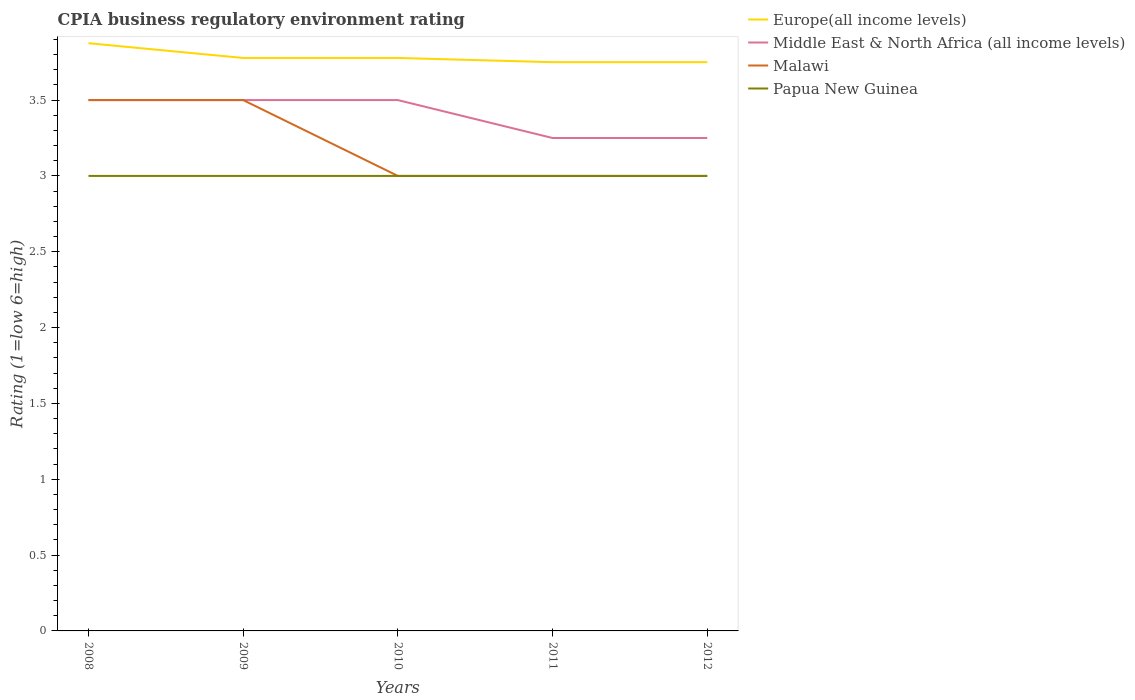Is the number of lines equal to the number of legend labels?
Offer a terse response. Yes. What is the total CPIA rating in Europe(all income levels) in the graph?
Provide a short and direct response. 0.12. What is the difference between the highest and the second highest CPIA rating in Middle East & North Africa (all income levels)?
Provide a short and direct response. 0.25. What is the difference between two consecutive major ticks on the Y-axis?
Provide a succinct answer. 0.5. How are the legend labels stacked?
Your answer should be very brief. Vertical. What is the title of the graph?
Provide a succinct answer. CPIA business regulatory environment rating. What is the label or title of the Y-axis?
Your answer should be very brief. Rating (1=low 6=high). What is the Rating (1=low 6=high) of Europe(all income levels) in 2008?
Offer a very short reply. 3.88. What is the Rating (1=low 6=high) of Malawi in 2008?
Offer a terse response. 3.5. What is the Rating (1=low 6=high) of Papua New Guinea in 2008?
Offer a terse response. 3. What is the Rating (1=low 6=high) of Europe(all income levels) in 2009?
Offer a terse response. 3.78. What is the Rating (1=low 6=high) of Malawi in 2009?
Provide a succinct answer. 3.5. What is the Rating (1=low 6=high) of Papua New Guinea in 2009?
Your answer should be very brief. 3. What is the Rating (1=low 6=high) of Europe(all income levels) in 2010?
Your answer should be very brief. 3.78. What is the Rating (1=low 6=high) in Malawi in 2010?
Make the answer very short. 3. What is the Rating (1=low 6=high) of Europe(all income levels) in 2011?
Offer a very short reply. 3.75. What is the Rating (1=low 6=high) in Middle East & North Africa (all income levels) in 2011?
Ensure brevity in your answer.  3.25. What is the Rating (1=low 6=high) in Papua New Guinea in 2011?
Provide a short and direct response. 3. What is the Rating (1=low 6=high) of Europe(all income levels) in 2012?
Keep it short and to the point. 3.75. What is the Rating (1=low 6=high) of Malawi in 2012?
Provide a succinct answer. 3. Across all years, what is the maximum Rating (1=low 6=high) of Europe(all income levels)?
Keep it short and to the point. 3.88. Across all years, what is the maximum Rating (1=low 6=high) of Middle East & North Africa (all income levels)?
Offer a very short reply. 3.5. Across all years, what is the minimum Rating (1=low 6=high) of Europe(all income levels)?
Keep it short and to the point. 3.75. Across all years, what is the minimum Rating (1=low 6=high) of Middle East & North Africa (all income levels)?
Your answer should be compact. 3.25. Across all years, what is the minimum Rating (1=low 6=high) of Malawi?
Offer a very short reply. 3. Across all years, what is the minimum Rating (1=low 6=high) of Papua New Guinea?
Keep it short and to the point. 3. What is the total Rating (1=low 6=high) of Europe(all income levels) in the graph?
Ensure brevity in your answer.  18.93. What is the total Rating (1=low 6=high) of Malawi in the graph?
Your answer should be compact. 16. What is the difference between the Rating (1=low 6=high) in Europe(all income levels) in 2008 and that in 2009?
Make the answer very short. 0.1. What is the difference between the Rating (1=low 6=high) of Europe(all income levels) in 2008 and that in 2010?
Provide a short and direct response. 0.1. What is the difference between the Rating (1=low 6=high) of Middle East & North Africa (all income levels) in 2008 and that in 2010?
Your answer should be compact. 0. What is the difference between the Rating (1=low 6=high) of Malawi in 2008 and that in 2010?
Give a very brief answer. 0.5. What is the difference between the Rating (1=low 6=high) of Papua New Guinea in 2008 and that in 2010?
Ensure brevity in your answer.  0. What is the difference between the Rating (1=low 6=high) in Malawi in 2008 and that in 2011?
Make the answer very short. 0.5. What is the difference between the Rating (1=low 6=high) in Europe(all income levels) in 2008 and that in 2012?
Keep it short and to the point. 0.12. What is the difference between the Rating (1=low 6=high) in Middle East & North Africa (all income levels) in 2008 and that in 2012?
Keep it short and to the point. 0.25. What is the difference between the Rating (1=low 6=high) of Malawi in 2009 and that in 2010?
Provide a succinct answer. 0.5. What is the difference between the Rating (1=low 6=high) of Papua New Guinea in 2009 and that in 2010?
Offer a terse response. 0. What is the difference between the Rating (1=low 6=high) of Europe(all income levels) in 2009 and that in 2011?
Provide a short and direct response. 0.03. What is the difference between the Rating (1=low 6=high) of Europe(all income levels) in 2009 and that in 2012?
Offer a terse response. 0.03. What is the difference between the Rating (1=low 6=high) of Malawi in 2009 and that in 2012?
Offer a very short reply. 0.5. What is the difference between the Rating (1=low 6=high) in Papua New Guinea in 2009 and that in 2012?
Your response must be concise. 0. What is the difference between the Rating (1=low 6=high) of Europe(all income levels) in 2010 and that in 2011?
Keep it short and to the point. 0.03. What is the difference between the Rating (1=low 6=high) in Middle East & North Africa (all income levels) in 2010 and that in 2011?
Give a very brief answer. 0.25. What is the difference between the Rating (1=low 6=high) of Malawi in 2010 and that in 2011?
Your answer should be compact. 0. What is the difference between the Rating (1=low 6=high) of Papua New Guinea in 2010 and that in 2011?
Provide a succinct answer. 0. What is the difference between the Rating (1=low 6=high) of Europe(all income levels) in 2010 and that in 2012?
Offer a terse response. 0.03. What is the difference between the Rating (1=low 6=high) in Middle East & North Africa (all income levels) in 2010 and that in 2012?
Ensure brevity in your answer.  0.25. What is the difference between the Rating (1=low 6=high) of Malawi in 2010 and that in 2012?
Your answer should be very brief. 0. What is the difference between the Rating (1=low 6=high) of Europe(all income levels) in 2011 and that in 2012?
Offer a very short reply. 0. What is the difference between the Rating (1=low 6=high) of Middle East & North Africa (all income levels) in 2011 and that in 2012?
Your answer should be compact. 0. What is the difference between the Rating (1=low 6=high) in Malawi in 2011 and that in 2012?
Your answer should be compact. 0. What is the difference between the Rating (1=low 6=high) in Papua New Guinea in 2011 and that in 2012?
Provide a succinct answer. 0. What is the difference between the Rating (1=low 6=high) of Europe(all income levels) in 2008 and the Rating (1=low 6=high) of Middle East & North Africa (all income levels) in 2009?
Make the answer very short. 0.38. What is the difference between the Rating (1=low 6=high) of Europe(all income levels) in 2008 and the Rating (1=low 6=high) of Malawi in 2009?
Provide a short and direct response. 0.38. What is the difference between the Rating (1=low 6=high) in Europe(all income levels) in 2008 and the Rating (1=low 6=high) in Papua New Guinea in 2009?
Give a very brief answer. 0.88. What is the difference between the Rating (1=low 6=high) in Malawi in 2008 and the Rating (1=low 6=high) in Papua New Guinea in 2009?
Provide a short and direct response. 0.5. What is the difference between the Rating (1=low 6=high) in Europe(all income levels) in 2008 and the Rating (1=low 6=high) in Middle East & North Africa (all income levels) in 2010?
Ensure brevity in your answer.  0.38. What is the difference between the Rating (1=low 6=high) of Europe(all income levels) in 2008 and the Rating (1=low 6=high) of Malawi in 2010?
Keep it short and to the point. 0.88. What is the difference between the Rating (1=low 6=high) in Europe(all income levels) in 2008 and the Rating (1=low 6=high) in Papua New Guinea in 2010?
Offer a terse response. 0.88. What is the difference between the Rating (1=low 6=high) in Europe(all income levels) in 2008 and the Rating (1=low 6=high) in Papua New Guinea in 2011?
Your answer should be very brief. 0.88. What is the difference between the Rating (1=low 6=high) in Middle East & North Africa (all income levels) in 2008 and the Rating (1=low 6=high) in Malawi in 2011?
Offer a terse response. 0.5. What is the difference between the Rating (1=low 6=high) of Middle East & North Africa (all income levels) in 2008 and the Rating (1=low 6=high) of Papua New Guinea in 2011?
Offer a terse response. 0.5. What is the difference between the Rating (1=low 6=high) of Malawi in 2008 and the Rating (1=low 6=high) of Papua New Guinea in 2011?
Your answer should be very brief. 0.5. What is the difference between the Rating (1=low 6=high) of Europe(all income levels) in 2008 and the Rating (1=low 6=high) of Middle East & North Africa (all income levels) in 2012?
Offer a terse response. 0.62. What is the difference between the Rating (1=low 6=high) in Middle East & North Africa (all income levels) in 2008 and the Rating (1=low 6=high) in Malawi in 2012?
Offer a terse response. 0.5. What is the difference between the Rating (1=low 6=high) in Malawi in 2008 and the Rating (1=low 6=high) in Papua New Guinea in 2012?
Provide a succinct answer. 0.5. What is the difference between the Rating (1=low 6=high) in Europe(all income levels) in 2009 and the Rating (1=low 6=high) in Middle East & North Africa (all income levels) in 2010?
Your response must be concise. 0.28. What is the difference between the Rating (1=low 6=high) in Europe(all income levels) in 2009 and the Rating (1=low 6=high) in Malawi in 2010?
Offer a very short reply. 0.78. What is the difference between the Rating (1=low 6=high) in Europe(all income levels) in 2009 and the Rating (1=low 6=high) in Papua New Guinea in 2010?
Keep it short and to the point. 0.78. What is the difference between the Rating (1=low 6=high) in Middle East & North Africa (all income levels) in 2009 and the Rating (1=low 6=high) in Papua New Guinea in 2010?
Give a very brief answer. 0.5. What is the difference between the Rating (1=low 6=high) in Europe(all income levels) in 2009 and the Rating (1=low 6=high) in Middle East & North Africa (all income levels) in 2011?
Provide a short and direct response. 0.53. What is the difference between the Rating (1=low 6=high) of Europe(all income levels) in 2009 and the Rating (1=low 6=high) of Papua New Guinea in 2011?
Keep it short and to the point. 0.78. What is the difference between the Rating (1=low 6=high) in Middle East & North Africa (all income levels) in 2009 and the Rating (1=low 6=high) in Malawi in 2011?
Offer a very short reply. 0.5. What is the difference between the Rating (1=low 6=high) of Middle East & North Africa (all income levels) in 2009 and the Rating (1=low 6=high) of Papua New Guinea in 2011?
Make the answer very short. 0.5. What is the difference between the Rating (1=low 6=high) in Europe(all income levels) in 2009 and the Rating (1=low 6=high) in Middle East & North Africa (all income levels) in 2012?
Give a very brief answer. 0.53. What is the difference between the Rating (1=low 6=high) in Europe(all income levels) in 2009 and the Rating (1=low 6=high) in Papua New Guinea in 2012?
Make the answer very short. 0.78. What is the difference between the Rating (1=low 6=high) of Middle East & North Africa (all income levels) in 2009 and the Rating (1=low 6=high) of Malawi in 2012?
Your answer should be compact. 0.5. What is the difference between the Rating (1=low 6=high) in Middle East & North Africa (all income levels) in 2009 and the Rating (1=low 6=high) in Papua New Guinea in 2012?
Provide a short and direct response. 0.5. What is the difference between the Rating (1=low 6=high) in Europe(all income levels) in 2010 and the Rating (1=low 6=high) in Middle East & North Africa (all income levels) in 2011?
Provide a succinct answer. 0.53. What is the difference between the Rating (1=low 6=high) of Europe(all income levels) in 2010 and the Rating (1=low 6=high) of Malawi in 2011?
Give a very brief answer. 0.78. What is the difference between the Rating (1=low 6=high) of Europe(all income levels) in 2010 and the Rating (1=low 6=high) of Papua New Guinea in 2011?
Make the answer very short. 0.78. What is the difference between the Rating (1=low 6=high) in Middle East & North Africa (all income levels) in 2010 and the Rating (1=low 6=high) in Malawi in 2011?
Offer a very short reply. 0.5. What is the difference between the Rating (1=low 6=high) in Middle East & North Africa (all income levels) in 2010 and the Rating (1=low 6=high) in Papua New Guinea in 2011?
Provide a succinct answer. 0.5. What is the difference between the Rating (1=low 6=high) of Europe(all income levels) in 2010 and the Rating (1=low 6=high) of Middle East & North Africa (all income levels) in 2012?
Provide a short and direct response. 0.53. What is the difference between the Rating (1=low 6=high) of Europe(all income levels) in 2010 and the Rating (1=low 6=high) of Malawi in 2012?
Offer a terse response. 0.78. What is the difference between the Rating (1=low 6=high) of Europe(all income levels) in 2010 and the Rating (1=low 6=high) of Papua New Guinea in 2012?
Give a very brief answer. 0.78. What is the difference between the Rating (1=low 6=high) of Malawi in 2010 and the Rating (1=low 6=high) of Papua New Guinea in 2012?
Your answer should be very brief. 0. What is the difference between the Rating (1=low 6=high) in Europe(all income levels) in 2011 and the Rating (1=low 6=high) in Middle East & North Africa (all income levels) in 2012?
Offer a terse response. 0.5. What is the difference between the Rating (1=low 6=high) of Europe(all income levels) in 2011 and the Rating (1=low 6=high) of Malawi in 2012?
Keep it short and to the point. 0.75. What is the difference between the Rating (1=low 6=high) of Europe(all income levels) in 2011 and the Rating (1=low 6=high) of Papua New Guinea in 2012?
Ensure brevity in your answer.  0.75. What is the difference between the Rating (1=low 6=high) in Middle East & North Africa (all income levels) in 2011 and the Rating (1=low 6=high) in Malawi in 2012?
Keep it short and to the point. 0.25. What is the difference between the Rating (1=low 6=high) in Middle East & North Africa (all income levels) in 2011 and the Rating (1=low 6=high) in Papua New Guinea in 2012?
Provide a short and direct response. 0.25. What is the average Rating (1=low 6=high) in Europe(all income levels) per year?
Keep it short and to the point. 3.79. What is the average Rating (1=low 6=high) of Papua New Guinea per year?
Keep it short and to the point. 3. In the year 2008, what is the difference between the Rating (1=low 6=high) in Middle East & North Africa (all income levels) and Rating (1=low 6=high) in Malawi?
Make the answer very short. 0. In the year 2008, what is the difference between the Rating (1=low 6=high) in Middle East & North Africa (all income levels) and Rating (1=low 6=high) in Papua New Guinea?
Offer a terse response. 0.5. In the year 2009, what is the difference between the Rating (1=low 6=high) of Europe(all income levels) and Rating (1=low 6=high) of Middle East & North Africa (all income levels)?
Your response must be concise. 0.28. In the year 2009, what is the difference between the Rating (1=low 6=high) in Europe(all income levels) and Rating (1=low 6=high) in Malawi?
Provide a succinct answer. 0.28. In the year 2009, what is the difference between the Rating (1=low 6=high) of Middle East & North Africa (all income levels) and Rating (1=low 6=high) of Malawi?
Offer a terse response. 0. In the year 2010, what is the difference between the Rating (1=low 6=high) of Europe(all income levels) and Rating (1=low 6=high) of Middle East & North Africa (all income levels)?
Keep it short and to the point. 0.28. In the year 2010, what is the difference between the Rating (1=low 6=high) of Europe(all income levels) and Rating (1=low 6=high) of Papua New Guinea?
Provide a short and direct response. 0.78. In the year 2010, what is the difference between the Rating (1=low 6=high) in Middle East & North Africa (all income levels) and Rating (1=low 6=high) in Papua New Guinea?
Make the answer very short. 0.5. In the year 2010, what is the difference between the Rating (1=low 6=high) of Malawi and Rating (1=low 6=high) of Papua New Guinea?
Offer a very short reply. 0. In the year 2011, what is the difference between the Rating (1=low 6=high) of Europe(all income levels) and Rating (1=low 6=high) of Malawi?
Give a very brief answer. 0.75. In the year 2011, what is the difference between the Rating (1=low 6=high) in Middle East & North Africa (all income levels) and Rating (1=low 6=high) in Malawi?
Offer a very short reply. 0.25. In the year 2011, what is the difference between the Rating (1=low 6=high) in Middle East & North Africa (all income levels) and Rating (1=low 6=high) in Papua New Guinea?
Ensure brevity in your answer.  0.25. In the year 2012, what is the difference between the Rating (1=low 6=high) in Europe(all income levels) and Rating (1=low 6=high) in Malawi?
Make the answer very short. 0.75. In the year 2012, what is the difference between the Rating (1=low 6=high) in Middle East & North Africa (all income levels) and Rating (1=low 6=high) in Papua New Guinea?
Provide a short and direct response. 0.25. In the year 2012, what is the difference between the Rating (1=low 6=high) in Malawi and Rating (1=low 6=high) in Papua New Guinea?
Ensure brevity in your answer.  0. What is the ratio of the Rating (1=low 6=high) of Europe(all income levels) in 2008 to that in 2009?
Provide a succinct answer. 1.03. What is the ratio of the Rating (1=low 6=high) of Middle East & North Africa (all income levels) in 2008 to that in 2009?
Ensure brevity in your answer.  1. What is the ratio of the Rating (1=low 6=high) in Malawi in 2008 to that in 2009?
Ensure brevity in your answer.  1. What is the ratio of the Rating (1=low 6=high) of Papua New Guinea in 2008 to that in 2009?
Provide a succinct answer. 1. What is the ratio of the Rating (1=low 6=high) of Europe(all income levels) in 2008 to that in 2010?
Your answer should be compact. 1.03. What is the ratio of the Rating (1=low 6=high) in Middle East & North Africa (all income levels) in 2008 to that in 2010?
Offer a very short reply. 1. What is the ratio of the Rating (1=low 6=high) of Papua New Guinea in 2008 to that in 2010?
Provide a short and direct response. 1. What is the ratio of the Rating (1=low 6=high) in Middle East & North Africa (all income levels) in 2008 to that in 2011?
Make the answer very short. 1.08. What is the ratio of the Rating (1=low 6=high) in Malawi in 2008 to that in 2011?
Ensure brevity in your answer.  1.17. What is the ratio of the Rating (1=low 6=high) in Papua New Guinea in 2008 to that in 2011?
Offer a very short reply. 1. What is the ratio of the Rating (1=low 6=high) of Europe(all income levels) in 2008 to that in 2012?
Your response must be concise. 1.03. What is the ratio of the Rating (1=low 6=high) in Middle East & North Africa (all income levels) in 2008 to that in 2012?
Give a very brief answer. 1.08. What is the ratio of the Rating (1=low 6=high) in Papua New Guinea in 2008 to that in 2012?
Provide a succinct answer. 1. What is the ratio of the Rating (1=low 6=high) of Malawi in 2009 to that in 2010?
Provide a short and direct response. 1.17. What is the ratio of the Rating (1=low 6=high) in Europe(all income levels) in 2009 to that in 2011?
Your answer should be very brief. 1.01. What is the ratio of the Rating (1=low 6=high) of Malawi in 2009 to that in 2011?
Your response must be concise. 1.17. What is the ratio of the Rating (1=low 6=high) in Papua New Guinea in 2009 to that in 2011?
Provide a short and direct response. 1. What is the ratio of the Rating (1=low 6=high) in Europe(all income levels) in 2009 to that in 2012?
Provide a short and direct response. 1.01. What is the ratio of the Rating (1=low 6=high) of Middle East & North Africa (all income levels) in 2009 to that in 2012?
Provide a succinct answer. 1.08. What is the ratio of the Rating (1=low 6=high) in Papua New Guinea in 2009 to that in 2012?
Make the answer very short. 1. What is the ratio of the Rating (1=low 6=high) in Europe(all income levels) in 2010 to that in 2011?
Make the answer very short. 1.01. What is the ratio of the Rating (1=low 6=high) of Middle East & North Africa (all income levels) in 2010 to that in 2011?
Ensure brevity in your answer.  1.08. What is the ratio of the Rating (1=low 6=high) in Europe(all income levels) in 2010 to that in 2012?
Your response must be concise. 1.01. What is the ratio of the Rating (1=low 6=high) of Middle East & North Africa (all income levels) in 2010 to that in 2012?
Offer a terse response. 1.08. What is the ratio of the Rating (1=low 6=high) of Papua New Guinea in 2010 to that in 2012?
Offer a very short reply. 1. What is the difference between the highest and the second highest Rating (1=low 6=high) in Europe(all income levels)?
Provide a short and direct response. 0.1. What is the difference between the highest and the second highest Rating (1=low 6=high) of Malawi?
Provide a succinct answer. 0. What is the difference between the highest and the lowest Rating (1=low 6=high) in Europe(all income levels)?
Your answer should be very brief. 0.12. What is the difference between the highest and the lowest Rating (1=low 6=high) of Middle East & North Africa (all income levels)?
Your response must be concise. 0.25. 